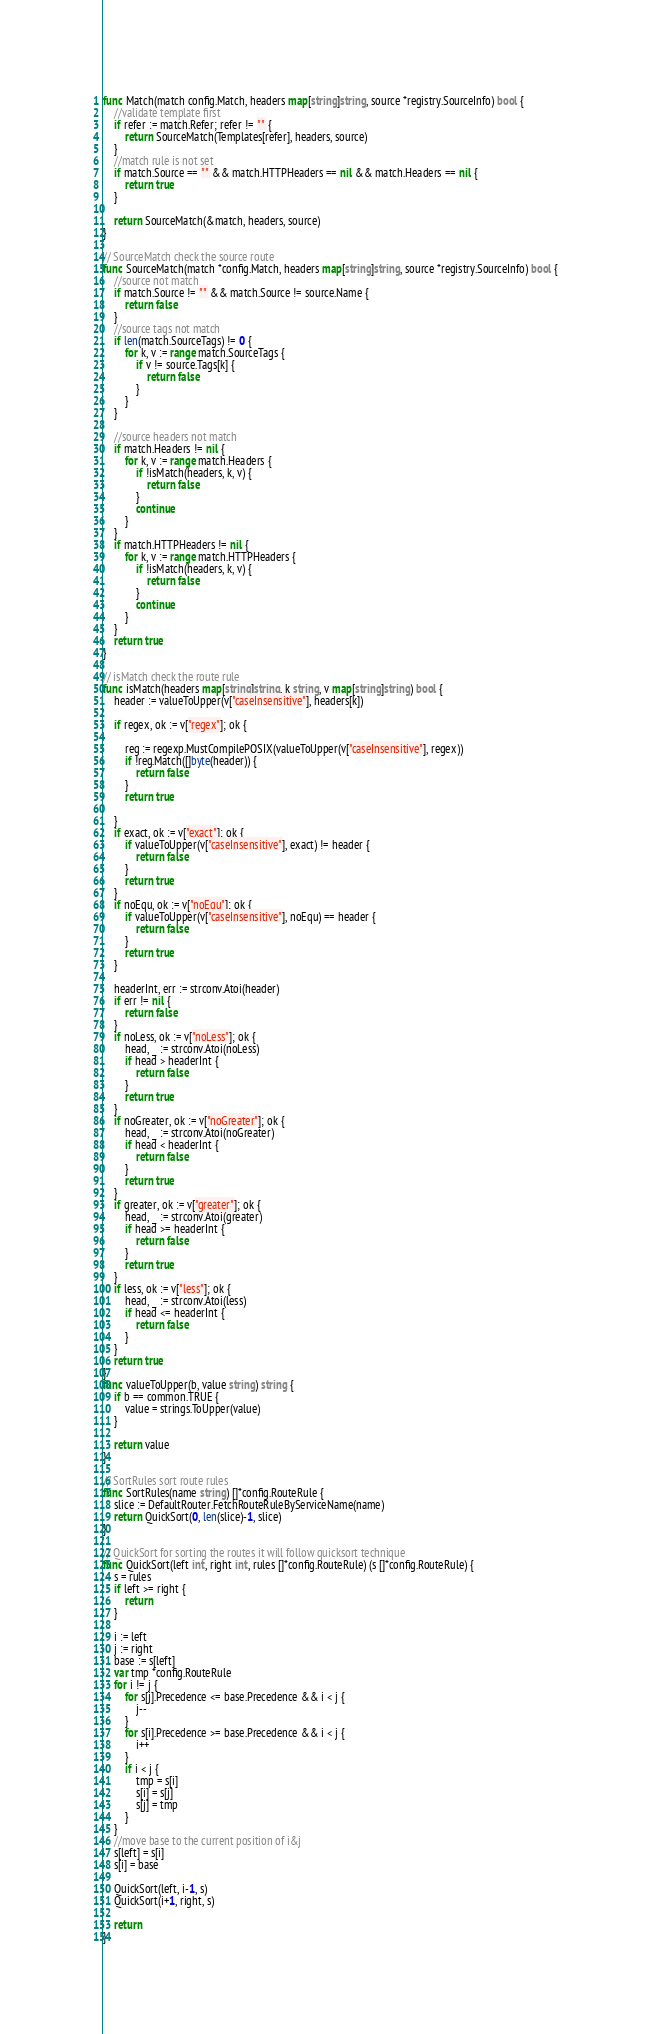<code> <loc_0><loc_0><loc_500><loc_500><_Go_>func Match(match config.Match, headers map[string]string, source *registry.SourceInfo) bool {
	//validate template first
	if refer := match.Refer; refer != "" {
		return SourceMatch(Templates[refer], headers, source)
	}
	//match rule is not set
	if match.Source == "" && match.HTTPHeaders == nil && match.Headers == nil {
		return true
	}

	return SourceMatch(&match, headers, source)
}

// SourceMatch check the source route
func SourceMatch(match *config.Match, headers map[string]string, source *registry.SourceInfo) bool {
	//source not match
	if match.Source != "" && match.Source != source.Name {
		return false
	}
	//source tags not match
	if len(match.SourceTags) != 0 {
		for k, v := range match.SourceTags {
			if v != source.Tags[k] {
				return false
			}
		}
	}

	//source headers not match
	if match.Headers != nil {
		for k, v := range match.Headers {
			if !isMatch(headers, k, v) {
				return false
			}
			continue
		}
	}
	if match.HTTPHeaders != nil {
		for k, v := range match.HTTPHeaders {
			if !isMatch(headers, k, v) {
				return false
			}
			continue
		}
	}
	return true
}

// isMatch check the route rule
func isMatch(headers map[string]string, k string, v map[string]string) bool {
	header := valueToUpper(v["caseInsensitive"], headers[k])

	if regex, ok := v["regex"]; ok {

		reg := regexp.MustCompilePOSIX(valueToUpper(v["caseInsensitive"], regex))
		if !reg.Match([]byte(header)) {
			return false
		}
		return true

	}
	if exact, ok := v["exact"]; ok {
		if valueToUpper(v["caseInsensitive"], exact) != header {
			return false
		}
		return true
	}
	if noEqu, ok := v["noEqu"]; ok {
		if valueToUpper(v["caseInsensitive"], noEqu) == header {
			return false
		}
		return true
	}

	headerInt, err := strconv.Atoi(header)
	if err != nil {
		return false
	}
	if noLess, ok := v["noLess"]; ok {
		head, _ := strconv.Atoi(noLess)
		if head > headerInt {
			return false
		}
		return true
	}
	if noGreater, ok := v["noGreater"]; ok {
		head, _ := strconv.Atoi(noGreater)
		if head < headerInt {
			return false
		}
		return true
	}
	if greater, ok := v["greater"]; ok {
		head, _ := strconv.Atoi(greater)
		if head >= headerInt {
			return false
		}
		return true
	}
	if less, ok := v["less"]; ok {
		head, _ := strconv.Atoi(less)
		if head <= headerInt {
			return false
		}
	}
	return true
}
func valueToUpper(b, value string) string {
	if b == common.TRUE {
		value = strings.ToUpper(value)
	}

	return value
}

// SortRules sort route rules
func SortRules(name string) []*config.RouteRule {
	slice := DefaultRouter.FetchRouteRuleByServiceName(name)
	return QuickSort(0, len(slice)-1, slice)
}

// QuickSort for sorting the routes it will follow quicksort technique
func QuickSort(left int, right int, rules []*config.RouteRule) (s []*config.RouteRule) {
	s = rules
	if left >= right {
		return
	}

	i := left
	j := right
	base := s[left]
	var tmp *config.RouteRule
	for i != j {
		for s[j].Precedence <= base.Precedence && i < j {
			j--
		}
		for s[i].Precedence >= base.Precedence && i < j {
			i++
		}
		if i < j {
			tmp = s[i]
			s[i] = s[j]
			s[j] = tmp
		}
	}
	//move base to the current position of i&j
	s[left] = s[i]
	s[i] = base

	QuickSort(left, i-1, s)
	QuickSort(i+1, right, s)

	return
}
</code> 